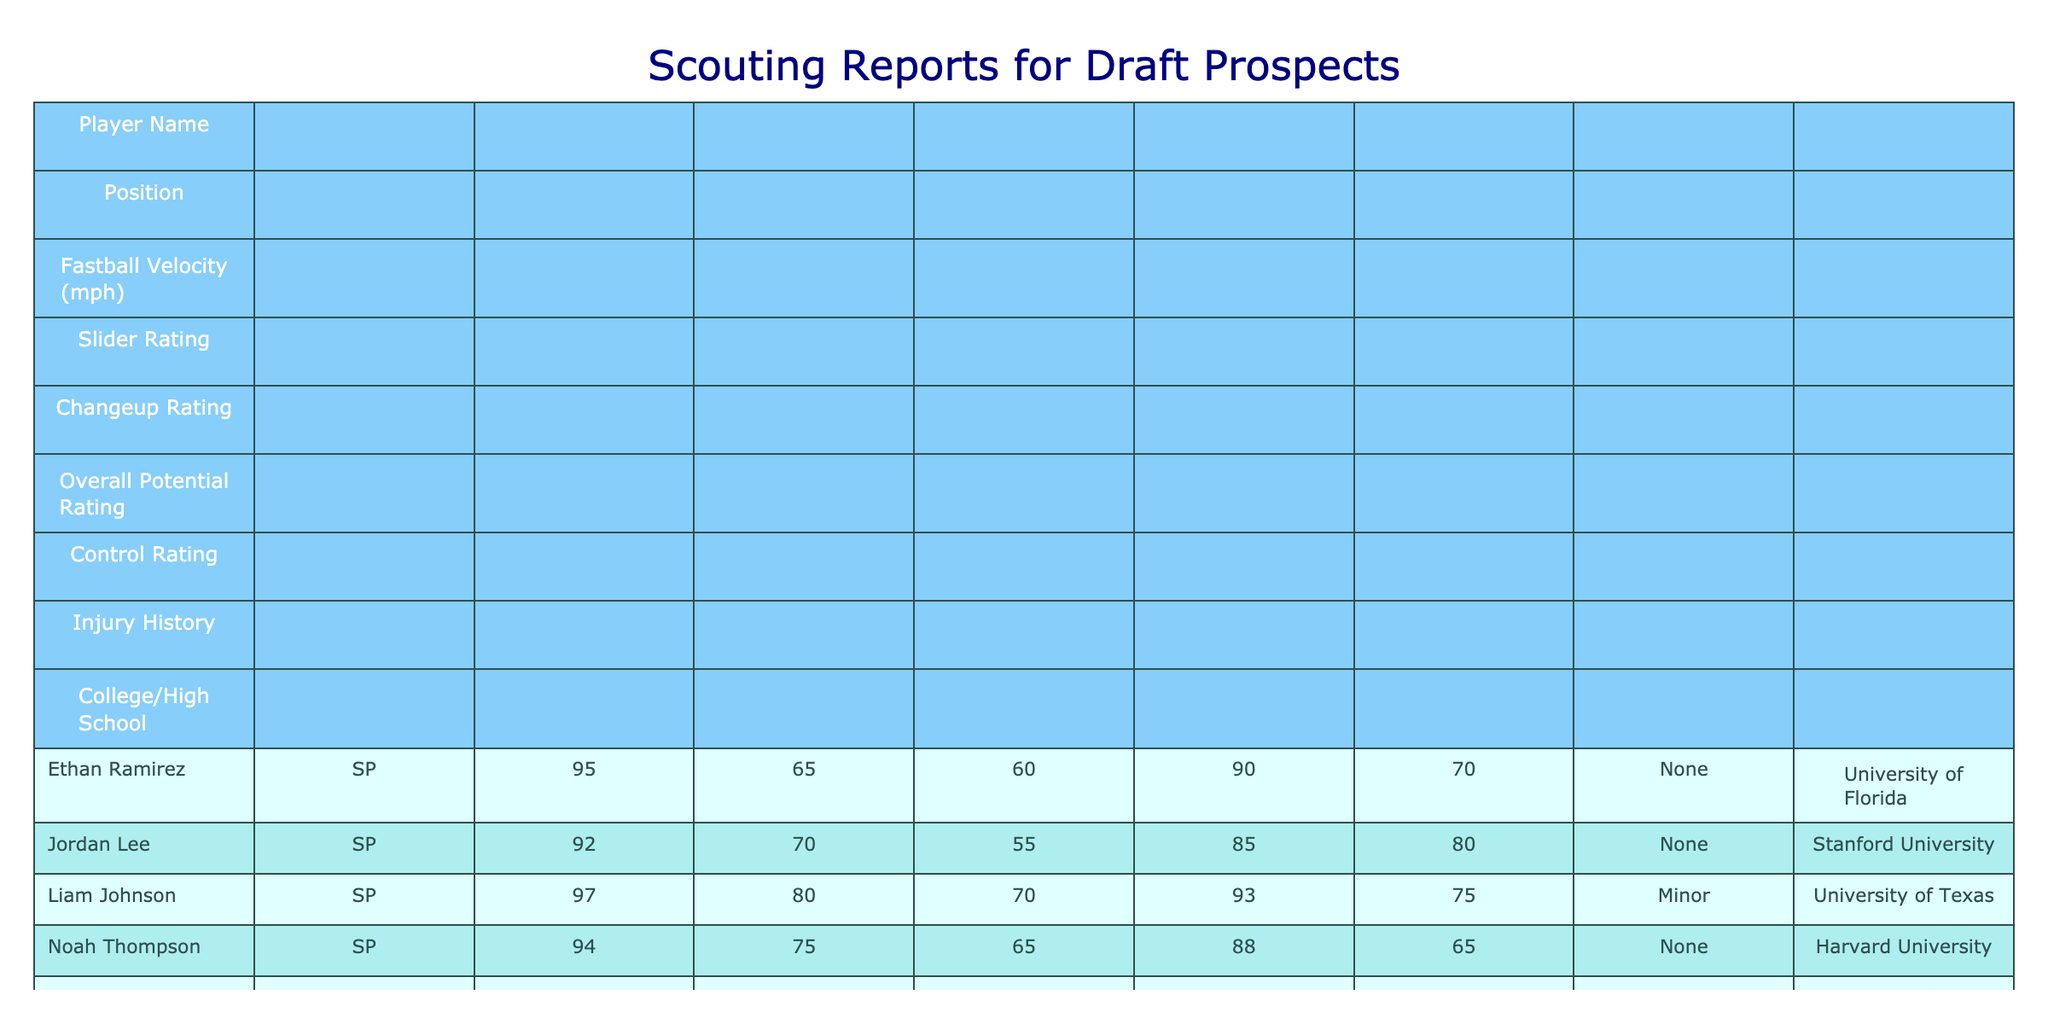What is the highest fastball velocity among the players? The table lists fastball velocities for each player. By scanning the "Fastball Velocity (mph)" column, Mason Wright's fastball velocity is the highest at 99 mph.
Answer: 99 Which player has the lowest overall potential rating? To find the lowest overall potential rating, I look at the "Overall Potential Rating" column. Benjamin Lewis has the lowest rating at 78.
Answer: 78 Are there any players with a major injury history? The "Injury History" column indicates if any players have a major injury history. Oliver King has a major injury history.
Answer: Yes What is the average control rating of all the players? To calculate the average control rating, I add all control ratings: (70 + 80 + 75 + 65 + 72 + 70 + 85 + 68 + 90 + 74) =  785. There are 10 players, so I divide 785 by 10, which equals 78.5.
Answer: 78.5 Which player has both the highest Slider Rating and the highest Changeup Rating? I compare the "Slider Rating" and "Changeup Rating" columns. Liam Johnson has the highest Slider Rating (80) and also a high Changeup Rating (70). However, Mason Wright has the highest Slider Rating (85) but Liam Johnson has the second highest for both. Thus, no player has both the highest for both categories.
Answer: None What is the control rating difference between the player with the highest potential rating and the player with the lowest? The player with the highest potential rating is Mason Wright with a rating of 95, and the player with the lowest is Benjamin Lewis with a rating of 78. Their control ratings are 70 and 90 respectively. The difference in control ratings is 90 - 70 = 20.
Answer: 20 How many players have an overall potential rating of 85 or higher? I scan the "Overall Potential Rating" for values of 85 or higher. The players meeting this criterion are Mason Wright, Liam Johnson, Ethan Ramirez, Noah Thompson, and Jordan Lee, totaling 5 players.
Answer: 5 What are the college affiliations for players with an overall potential rating of 90 or above? I check the "Overall Potential Rating" column for players with ratings of 90 or higher. These players are Mason Wright (University of Southern California), Liam Johnson (University of Texas), and Ethan Ramirez (University of Florida). Thus, the colleges are University of Southern California, University of Texas, and University of Florida.
Answer: University of Southern California, University of Texas, University of Florida 